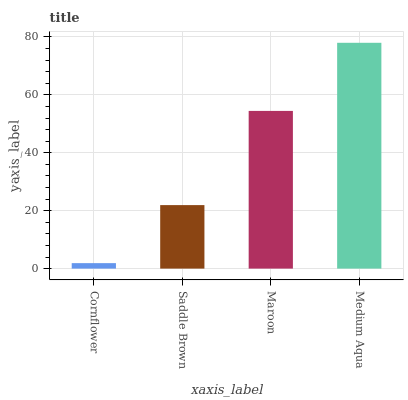Is Saddle Brown the minimum?
Answer yes or no. No. Is Saddle Brown the maximum?
Answer yes or no. No. Is Saddle Brown greater than Cornflower?
Answer yes or no. Yes. Is Cornflower less than Saddle Brown?
Answer yes or no. Yes. Is Cornflower greater than Saddle Brown?
Answer yes or no. No. Is Saddle Brown less than Cornflower?
Answer yes or no. No. Is Maroon the high median?
Answer yes or no. Yes. Is Saddle Brown the low median?
Answer yes or no. Yes. Is Cornflower the high median?
Answer yes or no. No. Is Cornflower the low median?
Answer yes or no. No. 